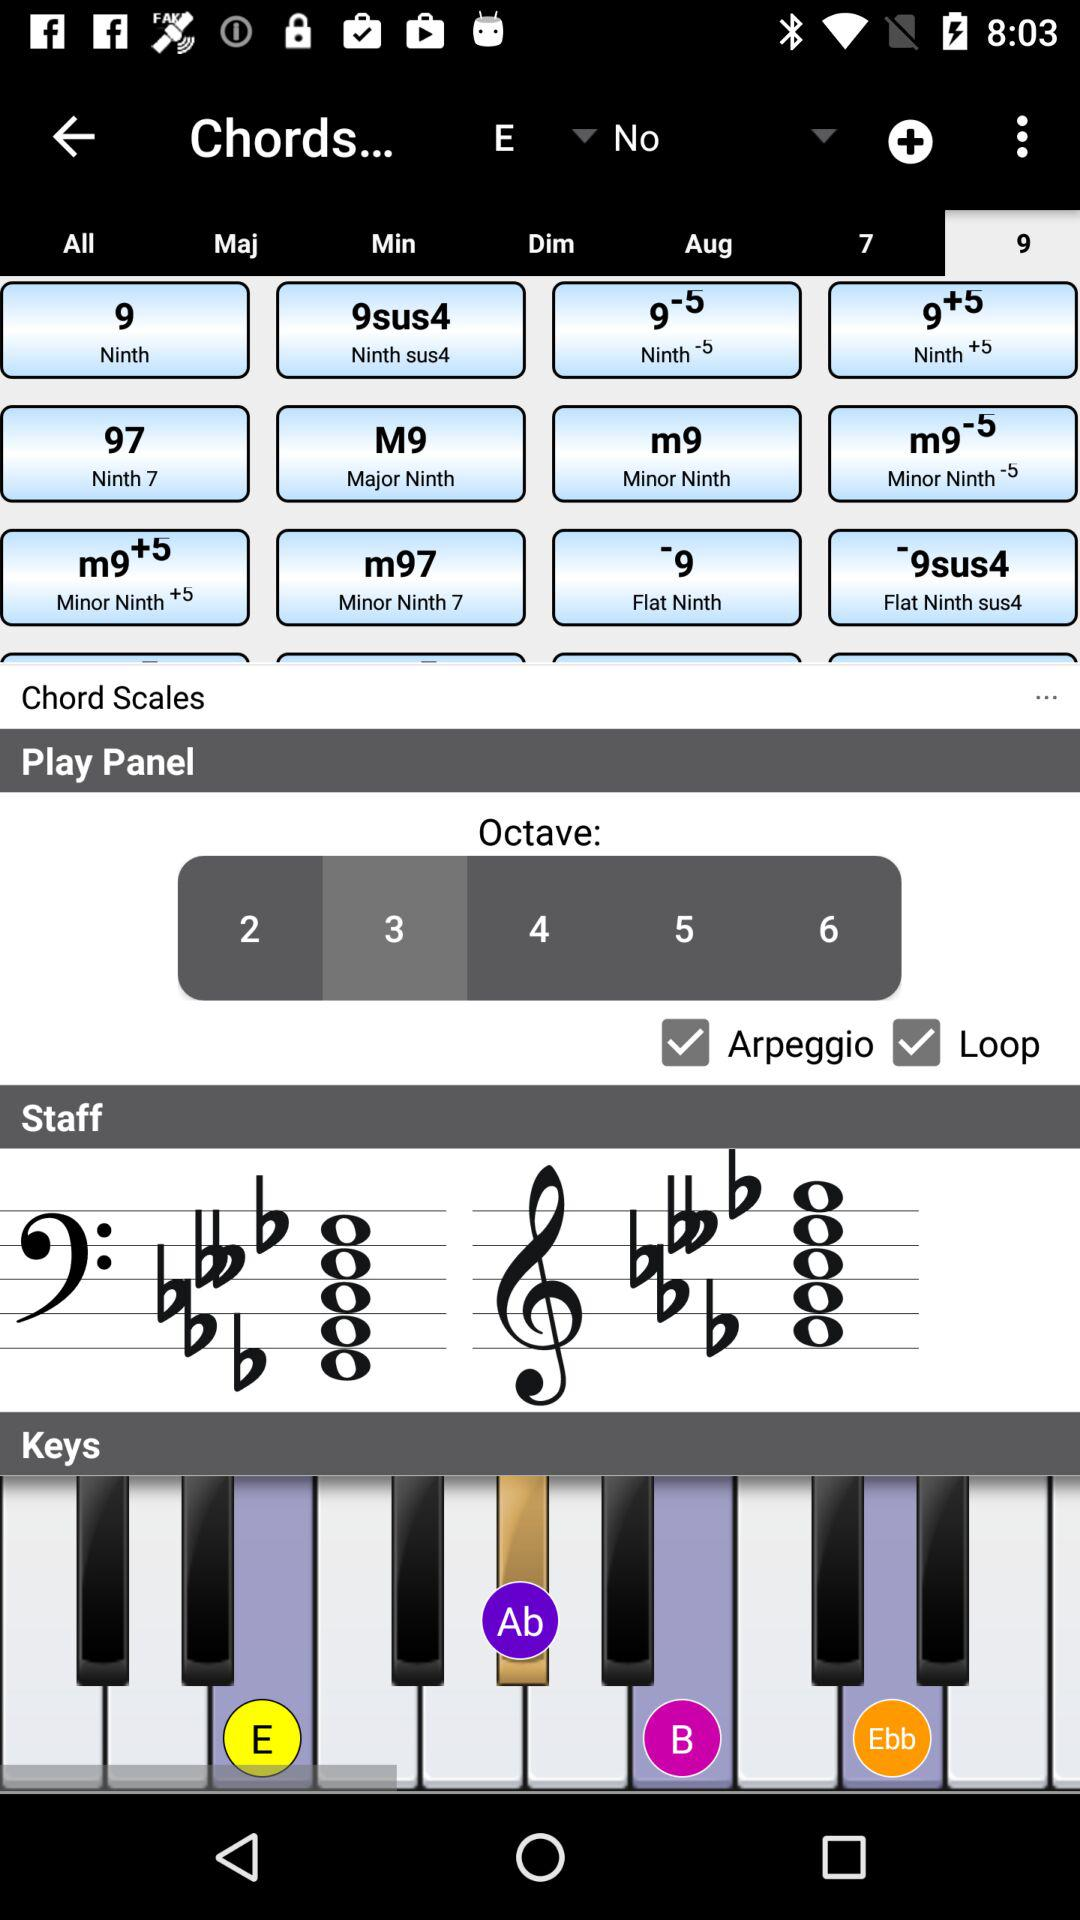What are pressed keys? Pressed keys are "E", "Ab", "B" and "Ebb". 